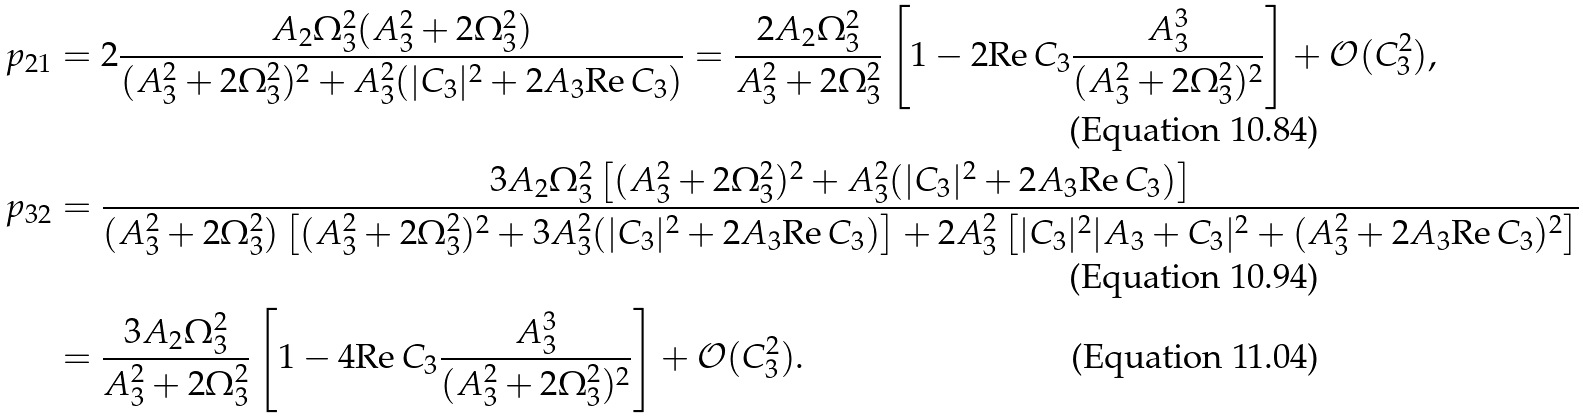Convert formula to latex. <formula><loc_0><loc_0><loc_500><loc_500>p _ { 2 1 } & = 2 \frac { A _ { 2 } \Omega _ { 3 } ^ { 2 } ( A _ { 3 } ^ { 2 } + 2 \Omega _ { 3 } ^ { 2 } ) } { ( A _ { 3 } ^ { 2 } + 2 \Omega _ { 3 } ^ { 2 } ) ^ { 2 } + A ^ { 2 } _ { 3 } ( | C _ { 3 } | ^ { 2 } + 2 A _ { 3 } \text {Re} \, C _ { 3 } ) } = \frac { 2 A _ { 2 } \Omega _ { 3 } ^ { 2 } } { A _ { 3 } ^ { 2 } + 2 \Omega _ { 3 } ^ { 2 } } \left [ 1 - 2 \text {Re} \, C _ { 3 } \frac { A _ { 3 } ^ { 3 } } { ( A _ { 3 } ^ { 2 } + 2 \Omega _ { 3 } ^ { 2 } ) ^ { 2 } } \right ] + \mathcal { O } ( C _ { 3 } ^ { 2 } ) , \\ p _ { 3 2 } & = \frac { 3 A _ { 2 } \Omega _ { 3 } ^ { 2 } \left [ ( A _ { 3 } ^ { 2 } + 2 \Omega _ { 3 } ^ { 2 } ) ^ { 2 } + A _ { 3 } ^ { 2 } ( | C _ { 3 } | ^ { 2 } + 2 A _ { 3 } \text {Re} \, C _ { 3 } ) \right ] } { ( A _ { 3 } ^ { 2 } + 2 \Omega _ { 3 } ^ { 2 } ) \left [ ( A _ { 3 } ^ { 2 } + 2 \Omega _ { 3 } ^ { 2 } ) ^ { 2 } + 3 A _ { 3 } ^ { 2 } ( | C _ { 3 } | ^ { 2 } + 2 A _ { 3 } \text {Re} \, C _ { 3 } ) \right ] + 2 A _ { 3 } ^ { 2 } \left [ | C _ { 3 } | ^ { 2 } | A _ { 3 } + C _ { 3 } | ^ { 2 } + ( A _ { 3 } ^ { 2 } + 2 A _ { 3 } \text {Re} \, C _ { 3 } ) ^ { 2 } \right ] } \\ & = \frac { 3 A _ { 2 } \Omega _ { 3 } ^ { 2 } } { A _ { 3 } ^ { 2 } + 2 \Omega _ { 3 } ^ { 2 } } \left [ 1 - 4 \text {Re} \, C _ { 3 } \frac { A _ { 3 } ^ { 3 } } { ( A _ { 3 } ^ { 2 } + 2 \Omega _ { 3 } ^ { 2 } ) ^ { 2 } } \right ] + \mathcal { O } ( C _ { 3 } ^ { 2 } ) .</formula> 